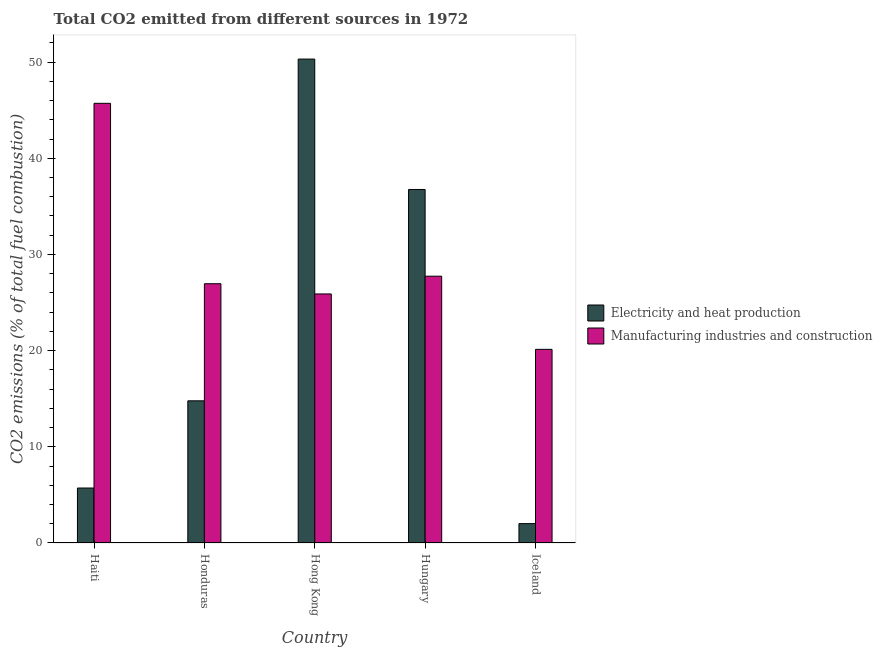How many different coloured bars are there?
Your response must be concise. 2. How many groups of bars are there?
Give a very brief answer. 5. What is the label of the 2nd group of bars from the left?
Make the answer very short. Honduras. What is the co2 emissions due to electricity and heat production in Honduras?
Make the answer very short. 14.78. Across all countries, what is the maximum co2 emissions due to manufacturing industries?
Offer a very short reply. 45.71. Across all countries, what is the minimum co2 emissions due to manufacturing industries?
Offer a very short reply. 20.13. In which country was the co2 emissions due to manufacturing industries maximum?
Make the answer very short. Haiti. In which country was the co2 emissions due to electricity and heat production minimum?
Your response must be concise. Iceland. What is the total co2 emissions due to manufacturing industries in the graph?
Make the answer very short. 146.44. What is the difference between the co2 emissions due to electricity and heat production in Hungary and that in Iceland?
Make the answer very short. 34.74. What is the difference between the co2 emissions due to manufacturing industries in Iceland and the co2 emissions due to electricity and heat production in Honduras?
Give a very brief answer. 5.35. What is the average co2 emissions due to manufacturing industries per country?
Provide a succinct answer. 29.29. What is the difference between the co2 emissions due to manufacturing industries and co2 emissions due to electricity and heat production in Haiti?
Offer a terse response. 40. In how many countries, is the co2 emissions due to manufacturing industries greater than 12 %?
Keep it short and to the point. 5. What is the ratio of the co2 emissions due to manufacturing industries in Haiti to that in Iceland?
Your response must be concise. 2.27. Is the co2 emissions due to manufacturing industries in Honduras less than that in Hungary?
Give a very brief answer. Yes. Is the difference between the co2 emissions due to electricity and heat production in Honduras and Iceland greater than the difference between the co2 emissions due to manufacturing industries in Honduras and Iceland?
Your response must be concise. Yes. What is the difference between the highest and the second highest co2 emissions due to electricity and heat production?
Give a very brief answer. 13.56. What is the difference between the highest and the lowest co2 emissions due to electricity and heat production?
Offer a terse response. 48.3. What does the 2nd bar from the left in Hong Kong represents?
Provide a short and direct response. Manufacturing industries and construction. What does the 2nd bar from the right in Iceland represents?
Offer a very short reply. Electricity and heat production. How many bars are there?
Your answer should be very brief. 10. How many countries are there in the graph?
Make the answer very short. 5. Does the graph contain any zero values?
Keep it short and to the point. No. Does the graph contain grids?
Make the answer very short. No. Where does the legend appear in the graph?
Your response must be concise. Center right. What is the title of the graph?
Make the answer very short. Total CO2 emitted from different sources in 1972. What is the label or title of the X-axis?
Your response must be concise. Country. What is the label or title of the Y-axis?
Your answer should be compact. CO2 emissions (% of total fuel combustion). What is the CO2 emissions (% of total fuel combustion) in Electricity and heat production in Haiti?
Ensure brevity in your answer.  5.71. What is the CO2 emissions (% of total fuel combustion) of Manufacturing industries and construction in Haiti?
Offer a very short reply. 45.71. What is the CO2 emissions (% of total fuel combustion) of Electricity and heat production in Honduras?
Make the answer very short. 14.78. What is the CO2 emissions (% of total fuel combustion) in Manufacturing industries and construction in Honduras?
Your answer should be very brief. 26.96. What is the CO2 emissions (% of total fuel combustion) of Electricity and heat production in Hong Kong?
Ensure brevity in your answer.  50.32. What is the CO2 emissions (% of total fuel combustion) of Manufacturing industries and construction in Hong Kong?
Offer a terse response. 25.89. What is the CO2 emissions (% of total fuel combustion) of Electricity and heat production in Hungary?
Offer a terse response. 36.76. What is the CO2 emissions (% of total fuel combustion) in Manufacturing industries and construction in Hungary?
Your answer should be compact. 27.74. What is the CO2 emissions (% of total fuel combustion) in Electricity and heat production in Iceland?
Provide a succinct answer. 2.01. What is the CO2 emissions (% of total fuel combustion) in Manufacturing industries and construction in Iceland?
Offer a terse response. 20.13. Across all countries, what is the maximum CO2 emissions (% of total fuel combustion) of Electricity and heat production?
Your answer should be very brief. 50.32. Across all countries, what is the maximum CO2 emissions (% of total fuel combustion) of Manufacturing industries and construction?
Your response must be concise. 45.71. Across all countries, what is the minimum CO2 emissions (% of total fuel combustion) of Electricity and heat production?
Keep it short and to the point. 2.01. Across all countries, what is the minimum CO2 emissions (% of total fuel combustion) of Manufacturing industries and construction?
Provide a short and direct response. 20.13. What is the total CO2 emissions (% of total fuel combustion) in Electricity and heat production in the graph?
Give a very brief answer. 109.58. What is the total CO2 emissions (% of total fuel combustion) of Manufacturing industries and construction in the graph?
Your response must be concise. 146.44. What is the difference between the CO2 emissions (% of total fuel combustion) in Electricity and heat production in Haiti and that in Honduras?
Offer a very short reply. -9.07. What is the difference between the CO2 emissions (% of total fuel combustion) of Manufacturing industries and construction in Haiti and that in Honduras?
Your response must be concise. 18.76. What is the difference between the CO2 emissions (% of total fuel combustion) of Electricity and heat production in Haiti and that in Hong Kong?
Offer a very short reply. -44.6. What is the difference between the CO2 emissions (% of total fuel combustion) of Manufacturing industries and construction in Haiti and that in Hong Kong?
Ensure brevity in your answer.  19.82. What is the difference between the CO2 emissions (% of total fuel combustion) of Electricity and heat production in Haiti and that in Hungary?
Give a very brief answer. -31.04. What is the difference between the CO2 emissions (% of total fuel combustion) of Manufacturing industries and construction in Haiti and that in Hungary?
Keep it short and to the point. 17.97. What is the difference between the CO2 emissions (% of total fuel combustion) in Electricity and heat production in Haiti and that in Iceland?
Provide a succinct answer. 3.7. What is the difference between the CO2 emissions (% of total fuel combustion) of Manufacturing industries and construction in Haiti and that in Iceland?
Provide a succinct answer. 25.58. What is the difference between the CO2 emissions (% of total fuel combustion) in Electricity and heat production in Honduras and that in Hong Kong?
Give a very brief answer. -35.53. What is the difference between the CO2 emissions (% of total fuel combustion) in Manufacturing industries and construction in Honduras and that in Hong Kong?
Keep it short and to the point. 1.06. What is the difference between the CO2 emissions (% of total fuel combustion) of Electricity and heat production in Honduras and that in Hungary?
Your answer should be compact. -21.97. What is the difference between the CO2 emissions (% of total fuel combustion) in Manufacturing industries and construction in Honduras and that in Hungary?
Keep it short and to the point. -0.78. What is the difference between the CO2 emissions (% of total fuel combustion) of Electricity and heat production in Honduras and that in Iceland?
Offer a very short reply. 12.77. What is the difference between the CO2 emissions (% of total fuel combustion) in Manufacturing industries and construction in Honduras and that in Iceland?
Make the answer very short. 6.82. What is the difference between the CO2 emissions (% of total fuel combustion) of Electricity and heat production in Hong Kong and that in Hungary?
Provide a short and direct response. 13.56. What is the difference between the CO2 emissions (% of total fuel combustion) in Manufacturing industries and construction in Hong Kong and that in Hungary?
Your response must be concise. -1.85. What is the difference between the CO2 emissions (% of total fuel combustion) of Electricity and heat production in Hong Kong and that in Iceland?
Ensure brevity in your answer.  48.3. What is the difference between the CO2 emissions (% of total fuel combustion) of Manufacturing industries and construction in Hong Kong and that in Iceland?
Offer a very short reply. 5.76. What is the difference between the CO2 emissions (% of total fuel combustion) in Electricity and heat production in Hungary and that in Iceland?
Keep it short and to the point. 34.74. What is the difference between the CO2 emissions (% of total fuel combustion) in Manufacturing industries and construction in Hungary and that in Iceland?
Ensure brevity in your answer.  7.61. What is the difference between the CO2 emissions (% of total fuel combustion) of Electricity and heat production in Haiti and the CO2 emissions (% of total fuel combustion) of Manufacturing industries and construction in Honduras?
Provide a succinct answer. -21.24. What is the difference between the CO2 emissions (% of total fuel combustion) in Electricity and heat production in Haiti and the CO2 emissions (% of total fuel combustion) in Manufacturing industries and construction in Hong Kong?
Keep it short and to the point. -20.18. What is the difference between the CO2 emissions (% of total fuel combustion) in Electricity and heat production in Haiti and the CO2 emissions (% of total fuel combustion) in Manufacturing industries and construction in Hungary?
Provide a short and direct response. -22.03. What is the difference between the CO2 emissions (% of total fuel combustion) of Electricity and heat production in Haiti and the CO2 emissions (% of total fuel combustion) of Manufacturing industries and construction in Iceland?
Make the answer very short. -14.42. What is the difference between the CO2 emissions (% of total fuel combustion) of Electricity and heat production in Honduras and the CO2 emissions (% of total fuel combustion) of Manufacturing industries and construction in Hong Kong?
Your response must be concise. -11.11. What is the difference between the CO2 emissions (% of total fuel combustion) of Electricity and heat production in Honduras and the CO2 emissions (% of total fuel combustion) of Manufacturing industries and construction in Hungary?
Make the answer very short. -12.96. What is the difference between the CO2 emissions (% of total fuel combustion) of Electricity and heat production in Honduras and the CO2 emissions (% of total fuel combustion) of Manufacturing industries and construction in Iceland?
Provide a succinct answer. -5.35. What is the difference between the CO2 emissions (% of total fuel combustion) of Electricity and heat production in Hong Kong and the CO2 emissions (% of total fuel combustion) of Manufacturing industries and construction in Hungary?
Your answer should be compact. 22.58. What is the difference between the CO2 emissions (% of total fuel combustion) of Electricity and heat production in Hong Kong and the CO2 emissions (% of total fuel combustion) of Manufacturing industries and construction in Iceland?
Offer a very short reply. 30.18. What is the difference between the CO2 emissions (% of total fuel combustion) in Electricity and heat production in Hungary and the CO2 emissions (% of total fuel combustion) in Manufacturing industries and construction in Iceland?
Your answer should be compact. 16.62. What is the average CO2 emissions (% of total fuel combustion) in Electricity and heat production per country?
Offer a very short reply. 21.92. What is the average CO2 emissions (% of total fuel combustion) in Manufacturing industries and construction per country?
Offer a terse response. 29.29. What is the difference between the CO2 emissions (% of total fuel combustion) in Electricity and heat production and CO2 emissions (% of total fuel combustion) in Manufacturing industries and construction in Haiti?
Make the answer very short. -40. What is the difference between the CO2 emissions (% of total fuel combustion) in Electricity and heat production and CO2 emissions (% of total fuel combustion) in Manufacturing industries and construction in Honduras?
Your response must be concise. -12.17. What is the difference between the CO2 emissions (% of total fuel combustion) in Electricity and heat production and CO2 emissions (% of total fuel combustion) in Manufacturing industries and construction in Hong Kong?
Your response must be concise. 24.42. What is the difference between the CO2 emissions (% of total fuel combustion) of Electricity and heat production and CO2 emissions (% of total fuel combustion) of Manufacturing industries and construction in Hungary?
Make the answer very short. 9.02. What is the difference between the CO2 emissions (% of total fuel combustion) of Electricity and heat production and CO2 emissions (% of total fuel combustion) of Manufacturing industries and construction in Iceland?
Give a very brief answer. -18.12. What is the ratio of the CO2 emissions (% of total fuel combustion) in Electricity and heat production in Haiti to that in Honduras?
Your response must be concise. 0.39. What is the ratio of the CO2 emissions (% of total fuel combustion) of Manufacturing industries and construction in Haiti to that in Honduras?
Provide a short and direct response. 1.7. What is the ratio of the CO2 emissions (% of total fuel combustion) of Electricity and heat production in Haiti to that in Hong Kong?
Offer a terse response. 0.11. What is the ratio of the CO2 emissions (% of total fuel combustion) of Manufacturing industries and construction in Haiti to that in Hong Kong?
Your response must be concise. 1.77. What is the ratio of the CO2 emissions (% of total fuel combustion) of Electricity and heat production in Haiti to that in Hungary?
Make the answer very short. 0.16. What is the ratio of the CO2 emissions (% of total fuel combustion) in Manufacturing industries and construction in Haiti to that in Hungary?
Offer a very short reply. 1.65. What is the ratio of the CO2 emissions (% of total fuel combustion) of Electricity and heat production in Haiti to that in Iceland?
Offer a very short reply. 2.84. What is the ratio of the CO2 emissions (% of total fuel combustion) in Manufacturing industries and construction in Haiti to that in Iceland?
Keep it short and to the point. 2.27. What is the ratio of the CO2 emissions (% of total fuel combustion) in Electricity and heat production in Honduras to that in Hong Kong?
Make the answer very short. 0.29. What is the ratio of the CO2 emissions (% of total fuel combustion) of Manufacturing industries and construction in Honduras to that in Hong Kong?
Make the answer very short. 1.04. What is the ratio of the CO2 emissions (% of total fuel combustion) in Electricity and heat production in Honduras to that in Hungary?
Your answer should be very brief. 0.4. What is the ratio of the CO2 emissions (% of total fuel combustion) in Manufacturing industries and construction in Honduras to that in Hungary?
Offer a very short reply. 0.97. What is the ratio of the CO2 emissions (% of total fuel combustion) of Electricity and heat production in Honduras to that in Iceland?
Your answer should be very brief. 7.34. What is the ratio of the CO2 emissions (% of total fuel combustion) of Manufacturing industries and construction in Honduras to that in Iceland?
Offer a terse response. 1.34. What is the ratio of the CO2 emissions (% of total fuel combustion) in Electricity and heat production in Hong Kong to that in Hungary?
Make the answer very short. 1.37. What is the ratio of the CO2 emissions (% of total fuel combustion) of Manufacturing industries and construction in Hong Kong to that in Hungary?
Give a very brief answer. 0.93. What is the ratio of the CO2 emissions (% of total fuel combustion) in Electricity and heat production in Hong Kong to that in Iceland?
Ensure brevity in your answer.  24.99. What is the ratio of the CO2 emissions (% of total fuel combustion) in Manufacturing industries and construction in Hong Kong to that in Iceland?
Your answer should be compact. 1.29. What is the ratio of the CO2 emissions (% of total fuel combustion) in Electricity and heat production in Hungary to that in Iceland?
Give a very brief answer. 18.26. What is the ratio of the CO2 emissions (% of total fuel combustion) in Manufacturing industries and construction in Hungary to that in Iceland?
Make the answer very short. 1.38. What is the difference between the highest and the second highest CO2 emissions (% of total fuel combustion) of Electricity and heat production?
Ensure brevity in your answer.  13.56. What is the difference between the highest and the second highest CO2 emissions (% of total fuel combustion) of Manufacturing industries and construction?
Ensure brevity in your answer.  17.97. What is the difference between the highest and the lowest CO2 emissions (% of total fuel combustion) of Electricity and heat production?
Ensure brevity in your answer.  48.3. What is the difference between the highest and the lowest CO2 emissions (% of total fuel combustion) in Manufacturing industries and construction?
Provide a succinct answer. 25.58. 